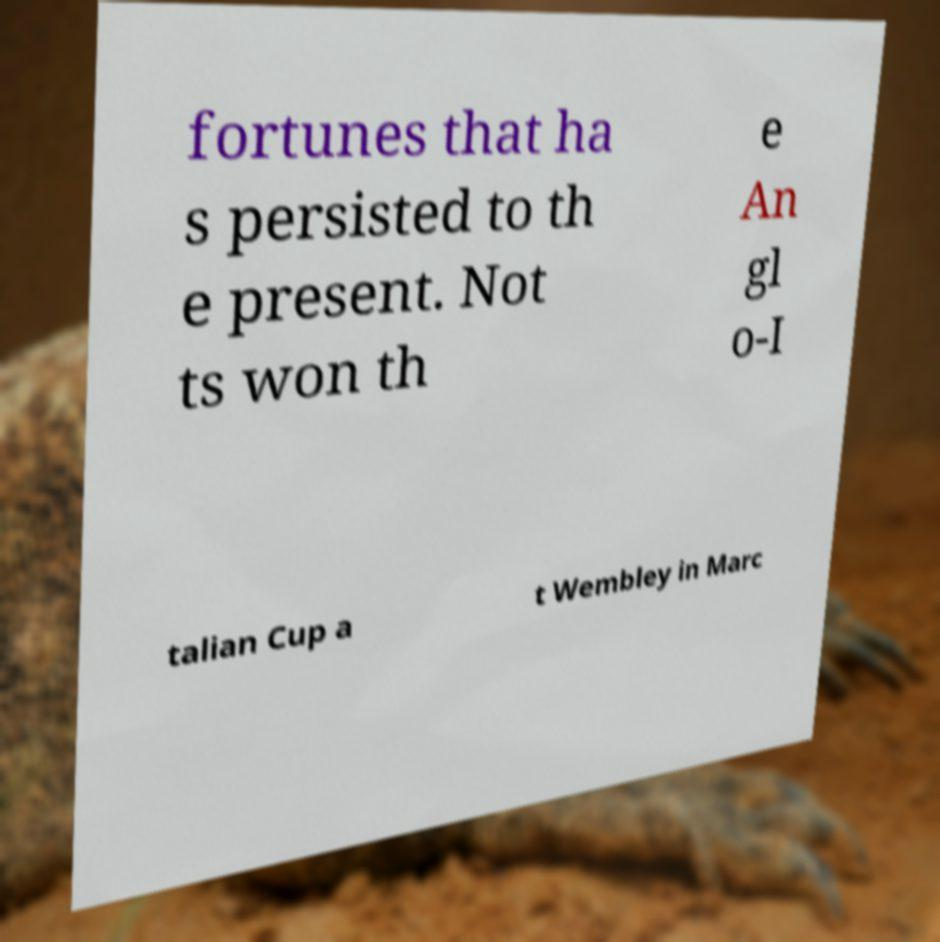Could you assist in decoding the text presented in this image and type it out clearly? fortunes that ha s persisted to th e present. Not ts won th e An gl o-I talian Cup a t Wembley in Marc 